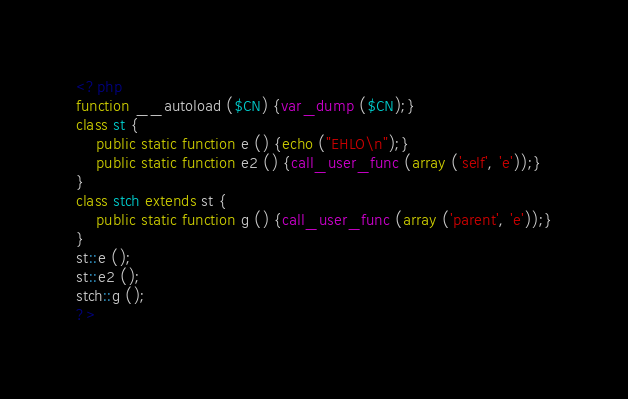Convert code to text. <code><loc_0><loc_0><loc_500><loc_500><_PHP_><?php
function __autoload ($CN) {var_dump ($CN);}
class st {
	public static function e () {echo ("EHLO\n");}
	public static function e2 () {call_user_func (array ('self', 'e'));}
}
class stch extends st {
	public static function g () {call_user_func (array ('parent', 'e'));}
}
st::e ();
st::e2 ();
stch::g ();
?>
</code> 